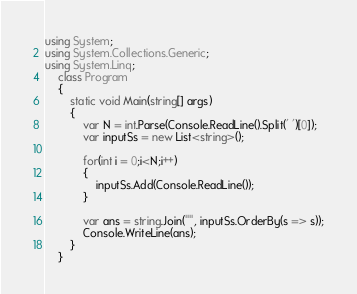<code> <loc_0><loc_0><loc_500><loc_500><_C#_>using System;
using System.Collections.Generic;
using System.Linq;
    class Program
    {
        static void Main(string[] args)
        {
            var N = int.Parse(Console.ReadLine().Split(' ')[0]);
            var inputSs = new List<string>();

            for(int i = 0;i<N;i++)
            {
                inputSs.Add(Console.ReadLine());
            }

            var ans = string.Join("", inputSs.OrderBy(s => s));
            Console.WriteLine(ans);
        }
    }</code> 